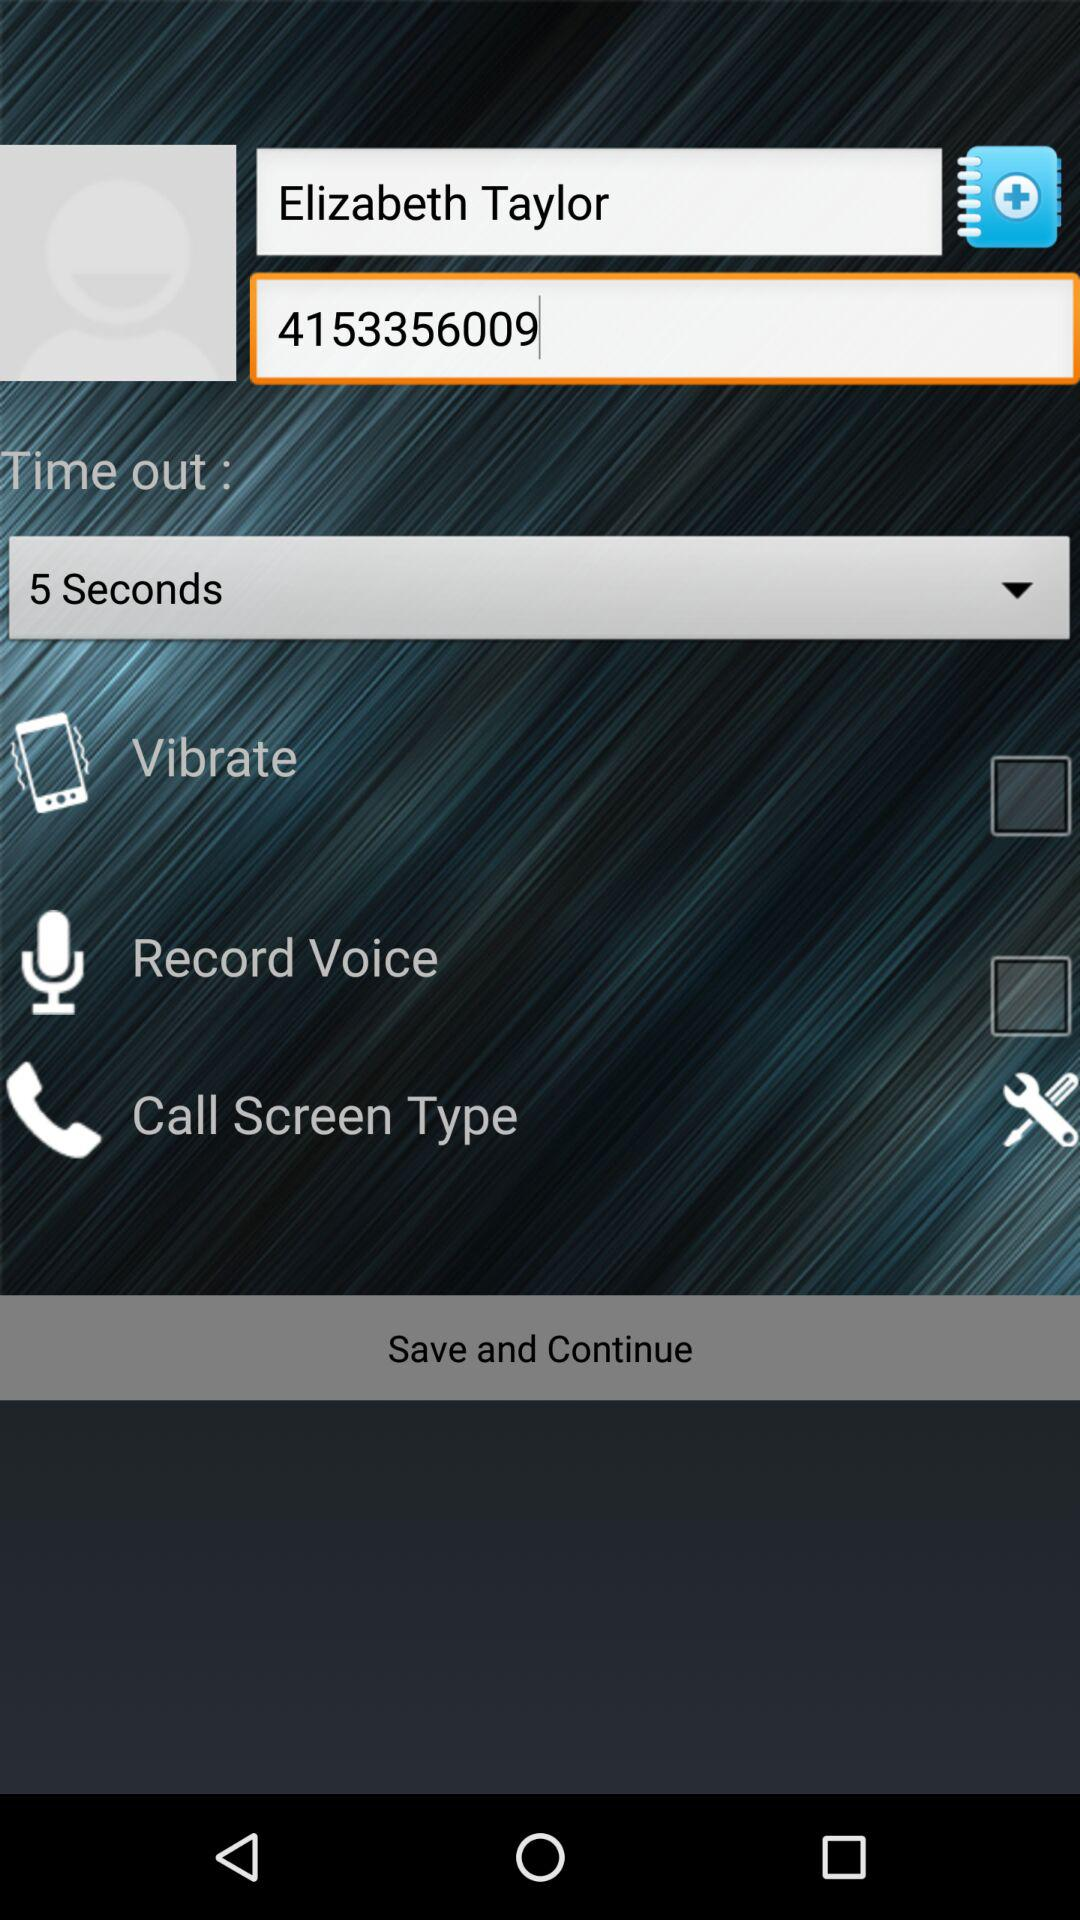How long is the selected "Time out"? The selected "Time out" is 5 seconds. 